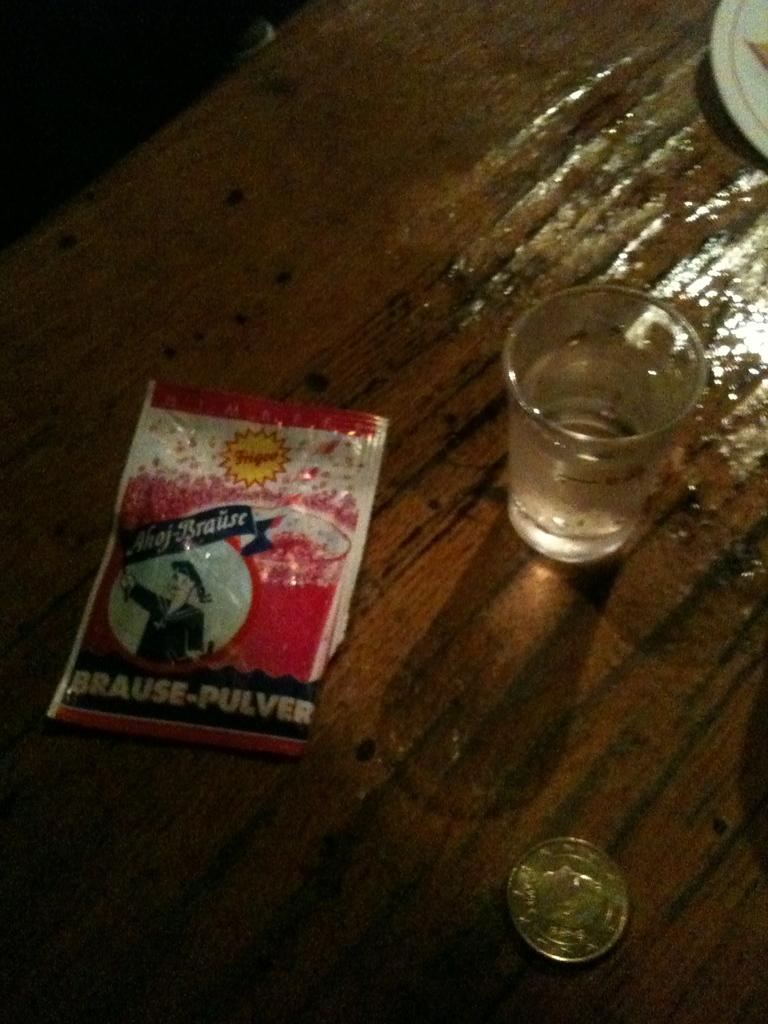<image>
Create a compact narrative representing the image presented. A pack of Brause-Pulver is on a table next to a glass. 